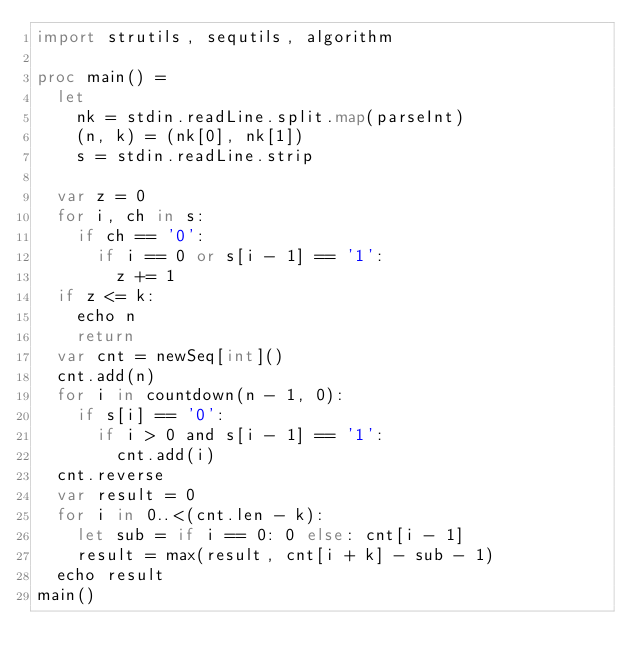<code> <loc_0><loc_0><loc_500><loc_500><_Nim_>import strutils, sequtils, algorithm

proc main() =
  let
    nk = stdin.readLine.split.map(parseInt)
    (n, k) = (nk[0], nk[1])
    s = stdin.readLine.strip
  
  var z = 0
  for i, ch in s:
    if ch == '0':
      if i == 0 or s[i - 1] == '1':
        z += 1
  if z <= k:
    echo n
    return
  var cnt = newSeq[int]()
  cnt.add(n)
  for i in countdown(n - 1, 0):
    if s[i] == '0':
      if i > 0 and s[i - 1] == '1':
        cnt.add(i)
  cnt.reverse
  var result = 0
  for i in 0..<(cnt.len - k):
    let sub = if i == 0: 0 else: cnt[i - 1]
    result = max(result, cnt[i + k] - sub - 1)
  echo result
main()</code> 